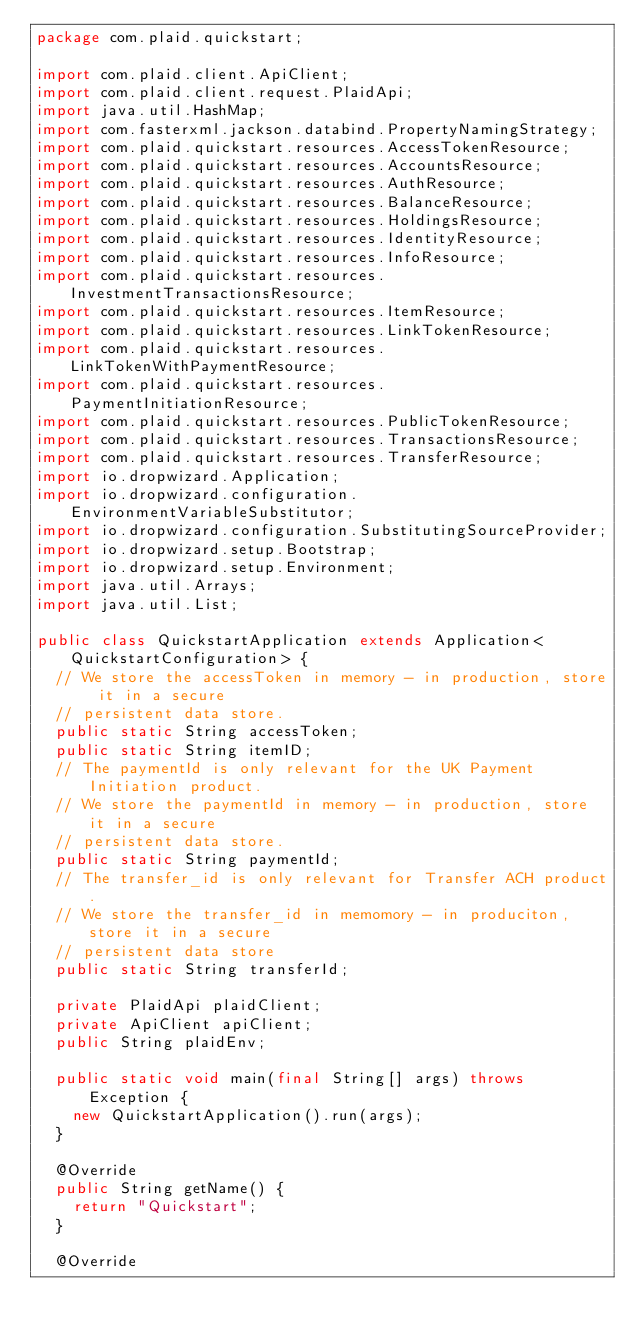<code> <loc_0><loc_0><loc_500><loc_500><_Java_>package com.plaid.quickstart;

import com.plaid.client.ApiClient;
import com.plaid.client.request.PlaidApi;
import java.util.HashMap;
import com.fasterxml.jackson.databind.PropertyNamingStrategy;
import com.plaid.quickstart.resources.AccessTokenResource;
import com.plaid.quickstart.resources.AccountsResource;
import com.plaid.quickstart.resources.AuthResource;
import com.plaid.quickstart.resources.BalanceResource;
import com.plaid.quickstart.resources.HoldingsResource;
import com.plaid.quickstart.resources.IdentityResource;
import com.plaid.quickstart.resources.InfoResource;
import com.plaid.quickstart.resources.InvestmentTransactionsResource;
import com.plaid.quickstart.resources.ItemResource;
import com.plaid.quickstart.resources.LinkTokenResource;
import com.plaid.quickstart.resources.LinkTokenWithPaymentResource;
import com.plaid.quickstart.resources.PaymentInitiationResource;
import com.plaid.quickstart.resources.PublicTokenResource;
import com.plaid.quickstart.resources.TransactionsResource;
import com.plaid.quickstart.resources.TransferResource;
import io.dropwizard.Application;
import io.dropwizard.configuration.EnvironmentVariableSubstitutor;
import io.dropwizard.configuration.SubstitutingSourceProvider;
import io.dropwizard.setup.Bootstrap;
import io.dropwizard.setup.Environment;
import java.util.Arrays;
import java.util.List;

public class QuickstartApplication extends Application<QuickstartConfiguration> {
  // We store the accessToken in memory - in production, store it in a secure
  // persistent data store.
  public static String accessToken;
  public static String itemID;
  // The paymentId is only relevant for the UK Payment Initiation product.
  // We store the paymentId in memory - in production, store it in a secure
  // persistent data store.
  public static String paymentId;
  // The transfer_id is only relevant for Transfer ACH product.
  // We store the transfer_id in memomory - in produciton, store it in a secure
  // persistent data store
  public static String transferId;

  private PlaidApi plaidClient;
  private ApiClient apiClient;
  public String plaidEnv;

  public static void main(final String[] args) throws Exception {
    new QuickstartApplication().run(args);
  }

  @Override
  public String getName() {
    return "Quickstart";
  }

  @Override</code> 